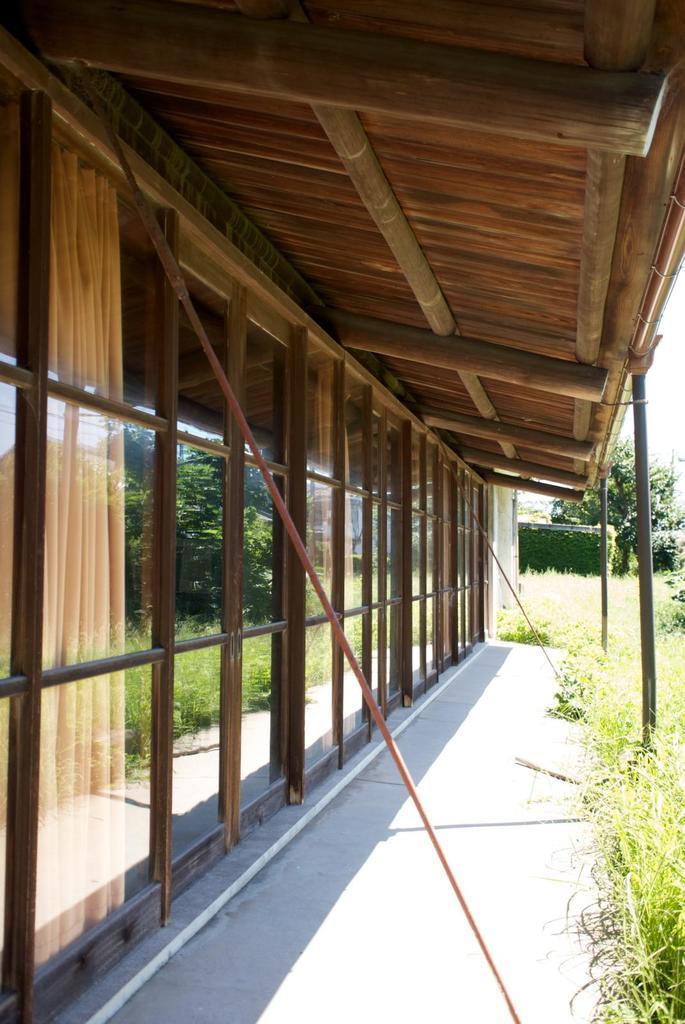How would you summarize this image in a sentence or two? In this image there is a path, at the top there is a roof, on the left side there is glass wall, on the right side there is grass. 